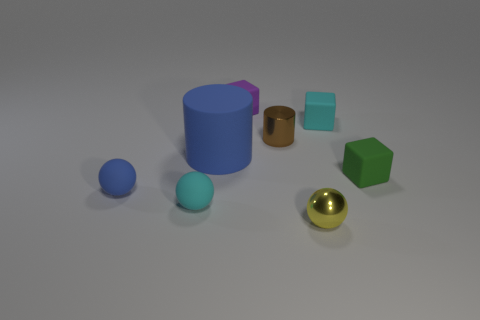Add 1 small rubber things. How many objects exist? 9 Subtract all blocks. How many objects are left? 5 Add 1 big cylinders. How many big cylinders exist? 2 Subtract 0 green cylinders. How many objects are left? 8 Subtract all green things. Subtract all cyan spheres. How many objects are left? 6 Add 5 large cylinders. How many large cylinders are left? 6 